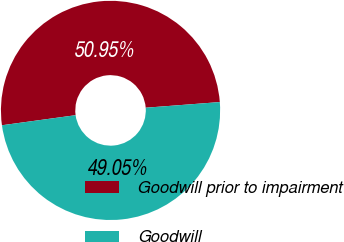<chart> <loc_0><loc_0><loc_500><loc_500><pie_chart><fcel>Goodwill prior to impairment<fcel>Goodwill<nl><fcel>50.95%<fcel>49.05%<nl></chart> 